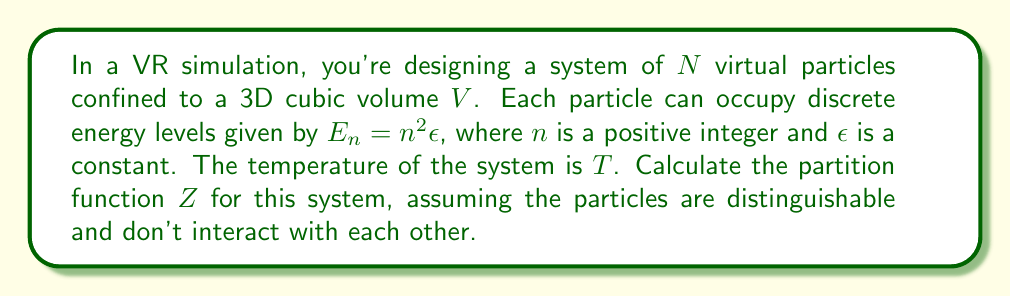Can you solve this math problem? Let's approach this step-by-step:

1) The partition function $Z$ for a system of $N$ distinguishable particles is given by:

   $$Z = (z_1)^N$$

   where $z_1$ is the partition function for a single particle.

2) For a single particle, the partition function is:

   $$z_1 = \sum_{n=1}^{\infty} e^{-\beta E_n}$$

   where $\beta = \frac{1}{k_B T}$, $k_B$ is Boltzmann's constant, and $T$ is the temperature.

3) Substituting the energy levels $E_n = n^2\epsilon$:

   $$z_1 = \sum_{n=1}^{\infty} e^{-\beta n^2\epsilon}$$

4) This sum doesn't have a simple closed form, but it can be expressed in terms of the Jacobi theta function $\theta_3(q)$:

   $$z_1 = \theta_3(e^{-\beta\epsilon}) - 1$$

   The subtraction of 1 is because our sum starts from $n=1$, while $\theta_3(q)$ includes the $n=0$ term.

5) Now, we can write the full partition function:

   $$Z = (\theta_3(e^{-\beta\epsilon}) - 1)^N$$

6) In terms of the temperature $T$:

   $$Z = (\theta_3(e^{-\epsilon/(k_B T)}) - 1)^N$$

This is the partition function for the system of virtual particles in your VR simulation.
Answer: $$Z = (\theta_3(e^{-\epsilon/(k_B T)}) - 1)^N$$ 